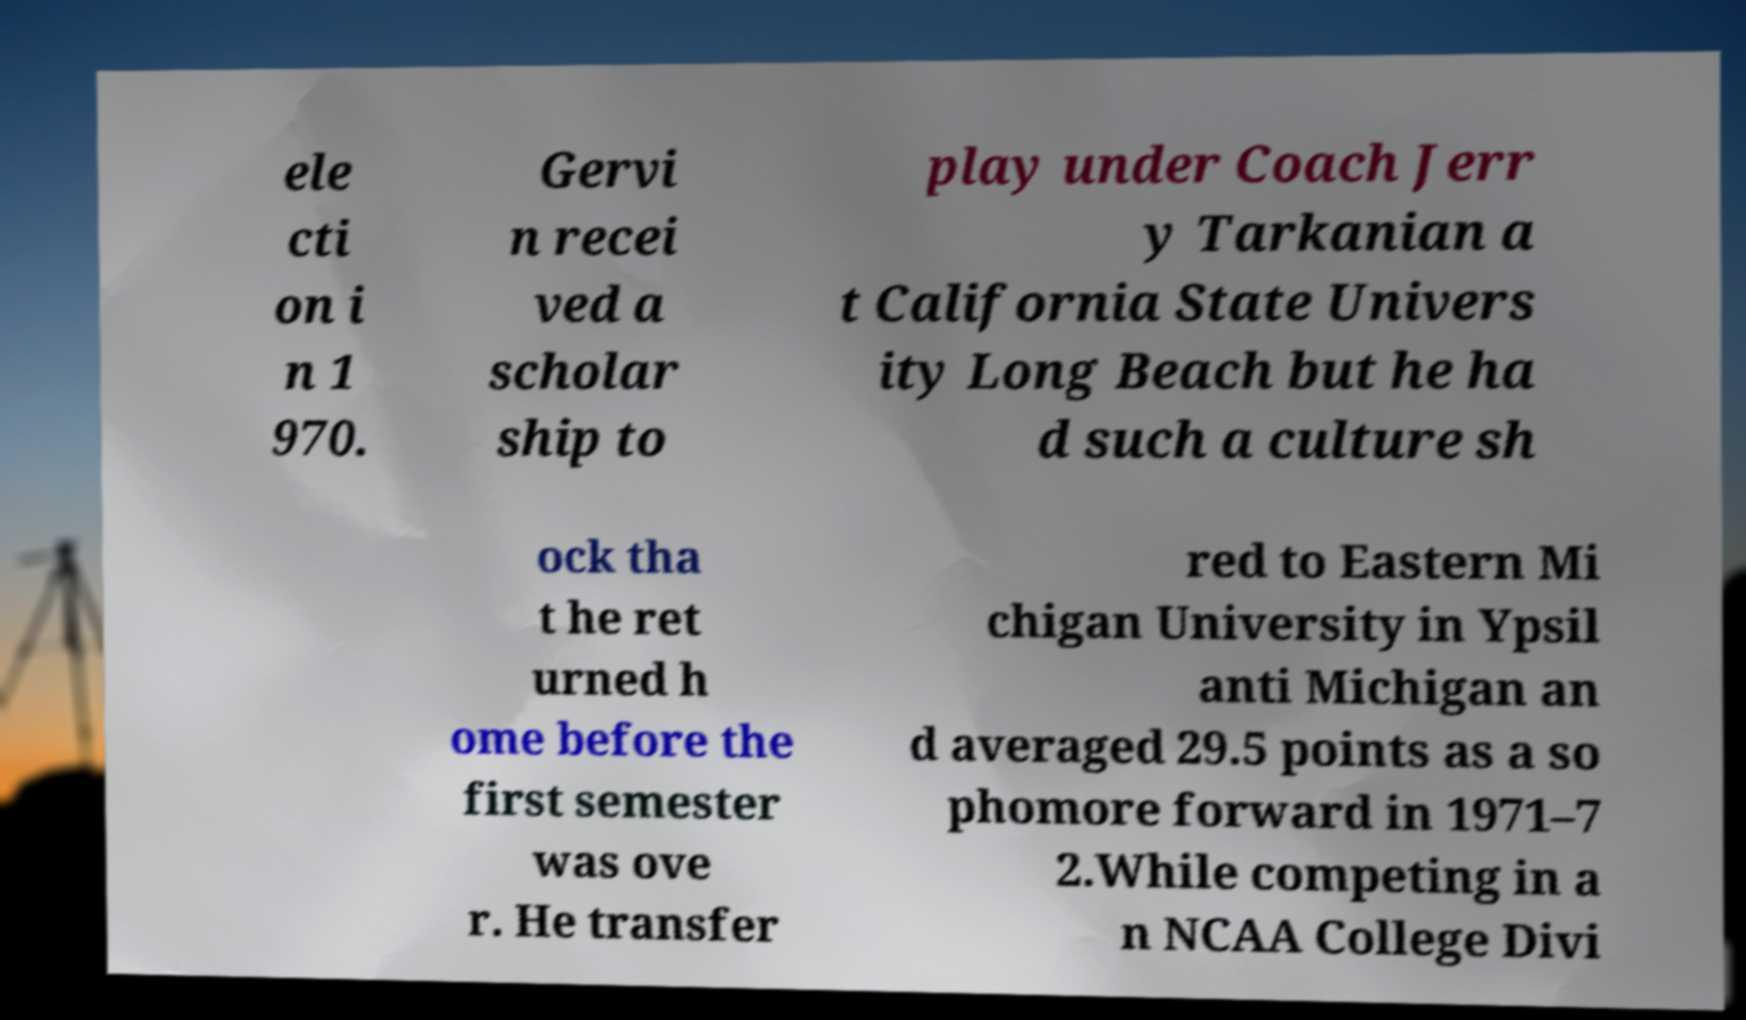Can you accurately transcribe the text from the provided image for me? ele cti on i n 1 970. Gervi n recei ved a scholar ship to play under Coach Jerr y Tarkanian a t California State Univers ity Long Beach but he ha d such a culture sh ock tha t he ret urned h ome before the first semester was ove r. He transfer red to Eastern Mi chigan University in Ypsil anti Michigan an d averaged 29.5 points as a so phomore forward in 1971–7 2.While competing in a n NCAA College Divi 